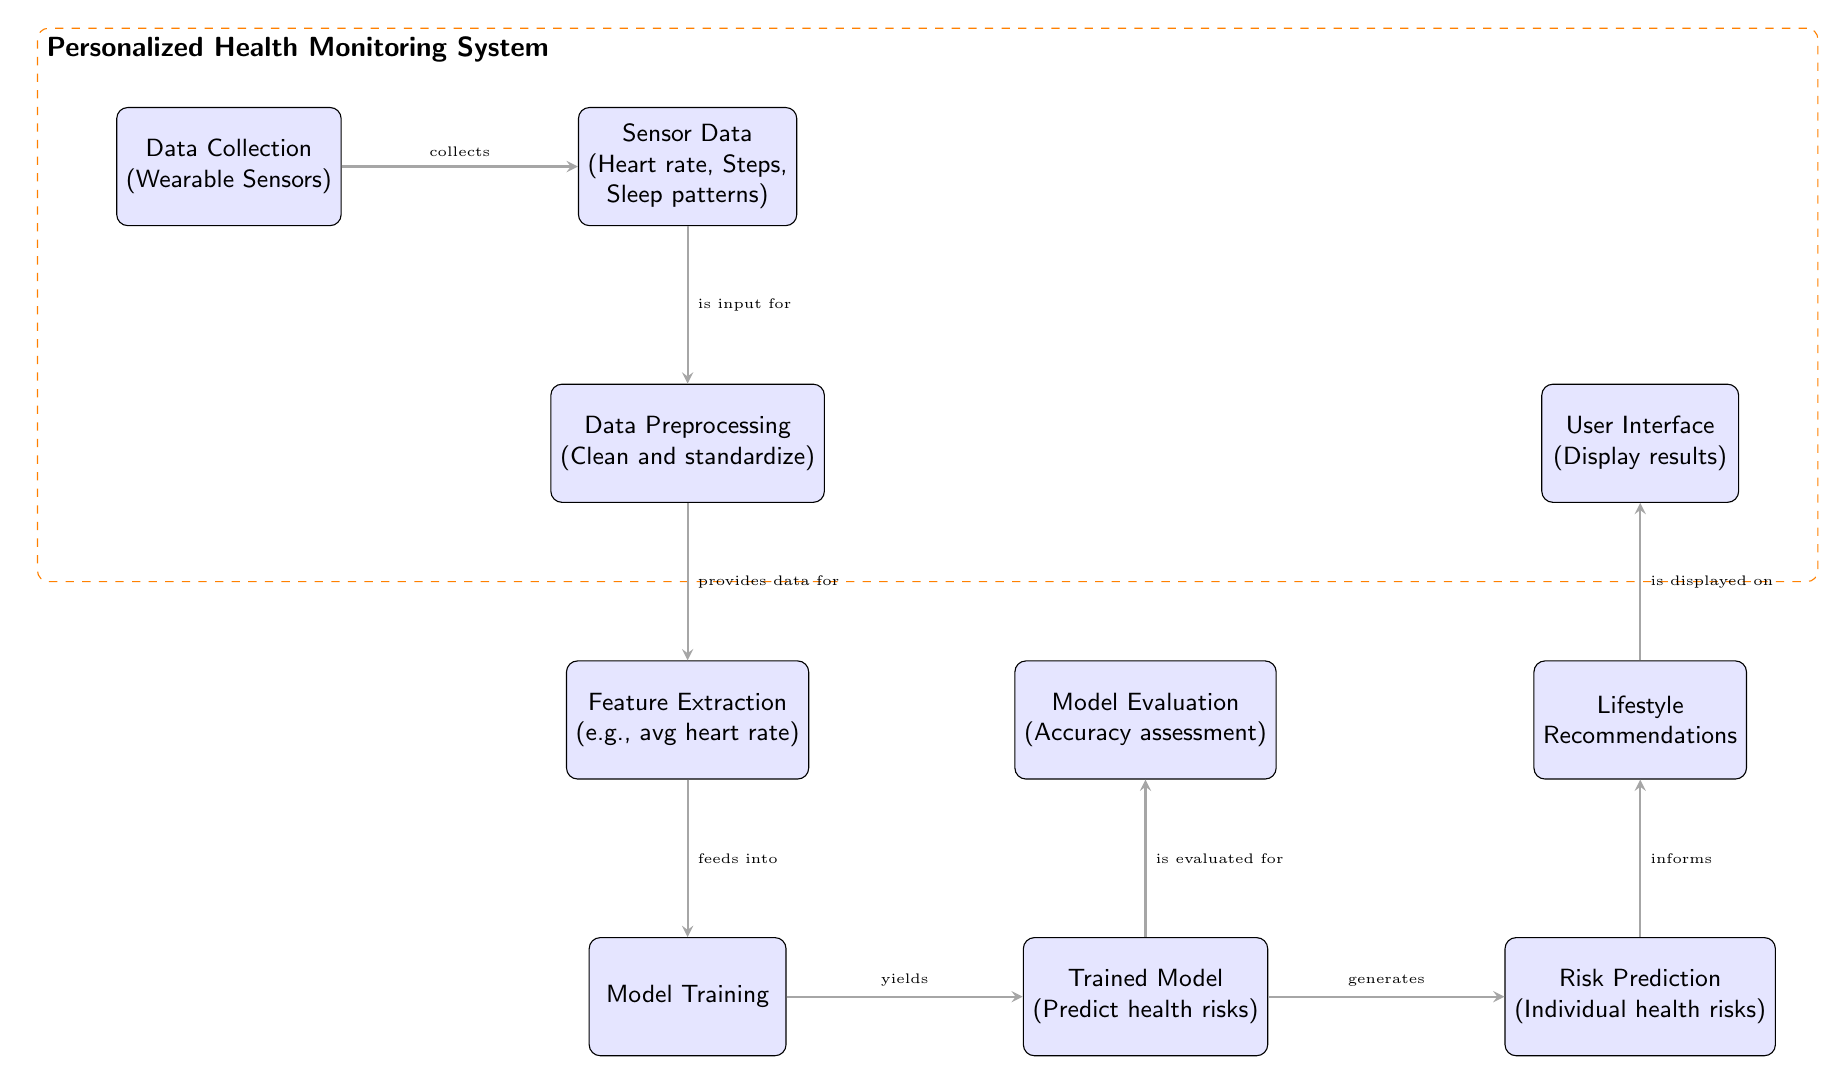What is the first step in the personalized health monitoring process? The diagram indicates that the first step in the process is "Data Collection (Wearable Sensors)" as it is the top node and initiates the flow of information.
Answer: Data Collection (Wearable Sensors) Which node receives input directly from the "Sensor Data" node? Following the flow from "Sensor Data", the next node below it is "Data Preprocessing", indicating that it receives the input from "Sensor Data".
Answer: Data Preprocessing How many nodes are involved in the model evaluation process? The diagram shows that "Model Evaluation" connects with "Trained Model" directly, indicating a one-to-one relationship; hence there is one relevant node specifically named "Model Evaluation".
Answer: One What is the output of the "Trained Model" node? The "Trained Model" node generates two outputs: "Risk Prediction (Individual health risks)" and "Model Evaluation (Accuracy assessment)". Focusing on its direct output related to health risks, it leads to "Risk Prediction".
Answer: Risk Prediction (Individual health risks) What is the relationship between "Risk Prediction" and "Lifestyle Recommendations"? The edge connecting these nodes indicates that "Risk Prediction" informs "Lifestyle Recommendations", demonstrating that the output of risk assessment directly influences lifestyle advice.
Answer: Informs Which process immediately follows "Feature Extraction"? The diagram indicates an arrow leading downward from "Feature Extraction" to the "Model Training" node, suggesting that the model training is the next step after feature extraction.
Answer: Model Training How many edges are in the diagram? By analyzing the flow of the diagram, there are a total of 8 edges connecting the various nodes, illustrating the paths of data through the system.
Answer: Eight What is displayed on the user interface? In the diagram, the node labeled "User Interface" indicates that it displays the results, which is specifically the information processed through the flow including risk predictions and lifestyle recommendations.
Answer: Display results 